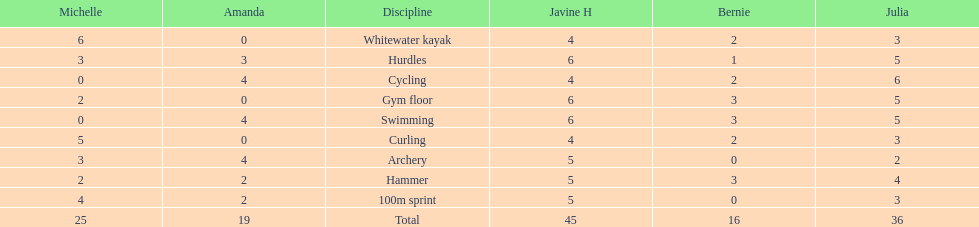Who is the faster runner? Javine H. 